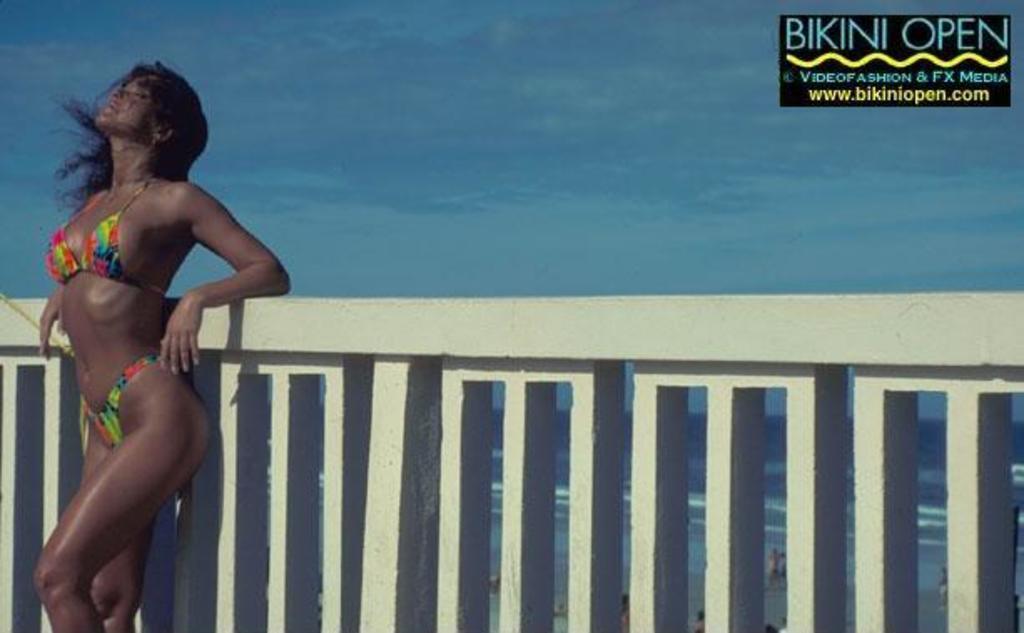Please provide a concise description of this image. In this picture we can see a woman standing at the fence and in the background we can see the sky with clouds. 